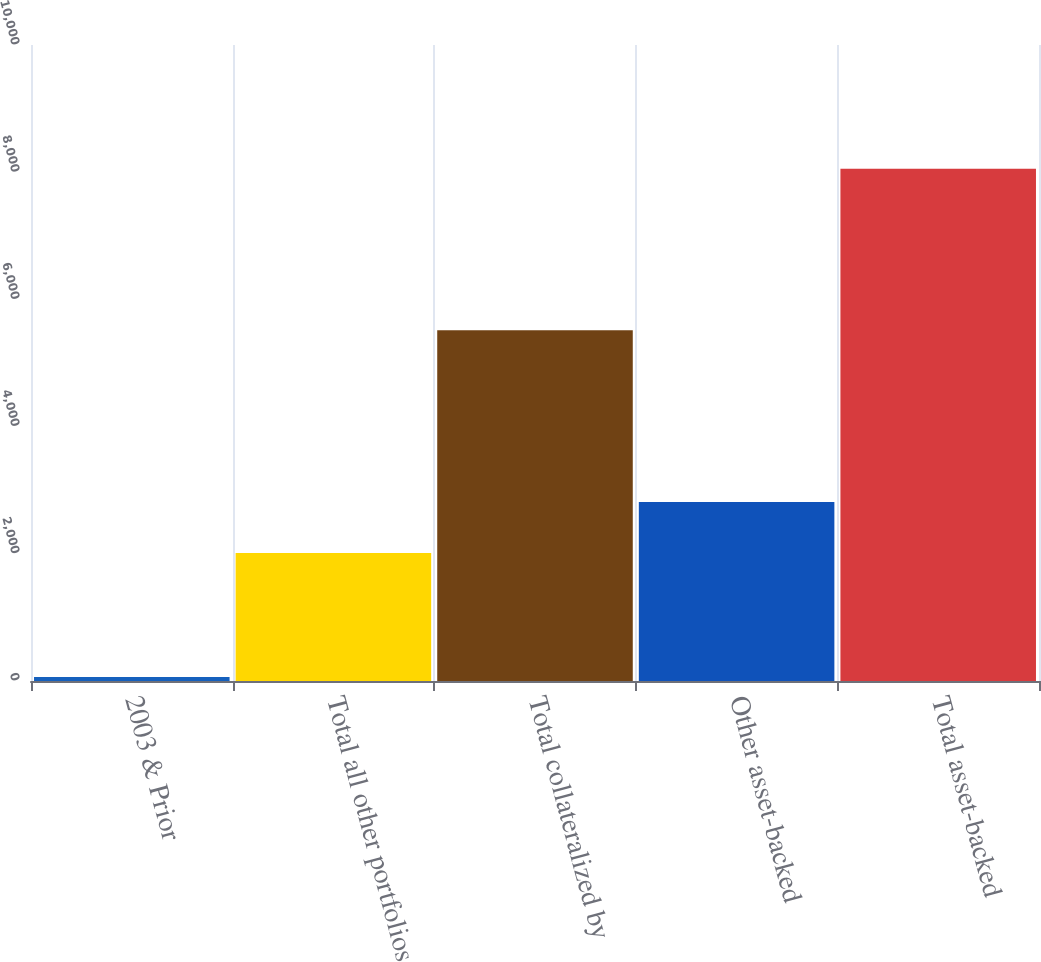Convert chart. <chart><loc_0><loc_0><loc_500><loc_500><bar_chart><fcel>2003 & Prior<fcel>Total all other portfolios<fcel>Total collateralized by<fcel>Other asset-backed<fcel>Total asset-backed<nl><fcel>63<fcel>2014<fcel>5515<fcel>2813.2<fcel>8055<nl></chart> 